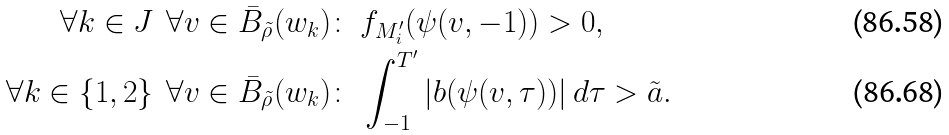Convert formula to latex. <formula><loc_0><loc_0><loc_500><loc_500>\forall k \in J \ \, \forall v \in \bar { B } _ { \tilde { \rho } } ( w _ { k } ) \colon & \ f _ { M _ { i } ^ { \prime } } ( \psi ( v , - 1 ) ) > 0 , \\ \forall k \in \{ 1 , 2 \} \ \, \forall v \in \bar { B } _ { \tilde { \rho } } ( w _ { k } ) \colon & \ \int _ { - 1 } ^ { T ^ { \prime } } | b ( \psi ( v , \tau ) ) | \, d \tau > \tilde { a } .</formula> 